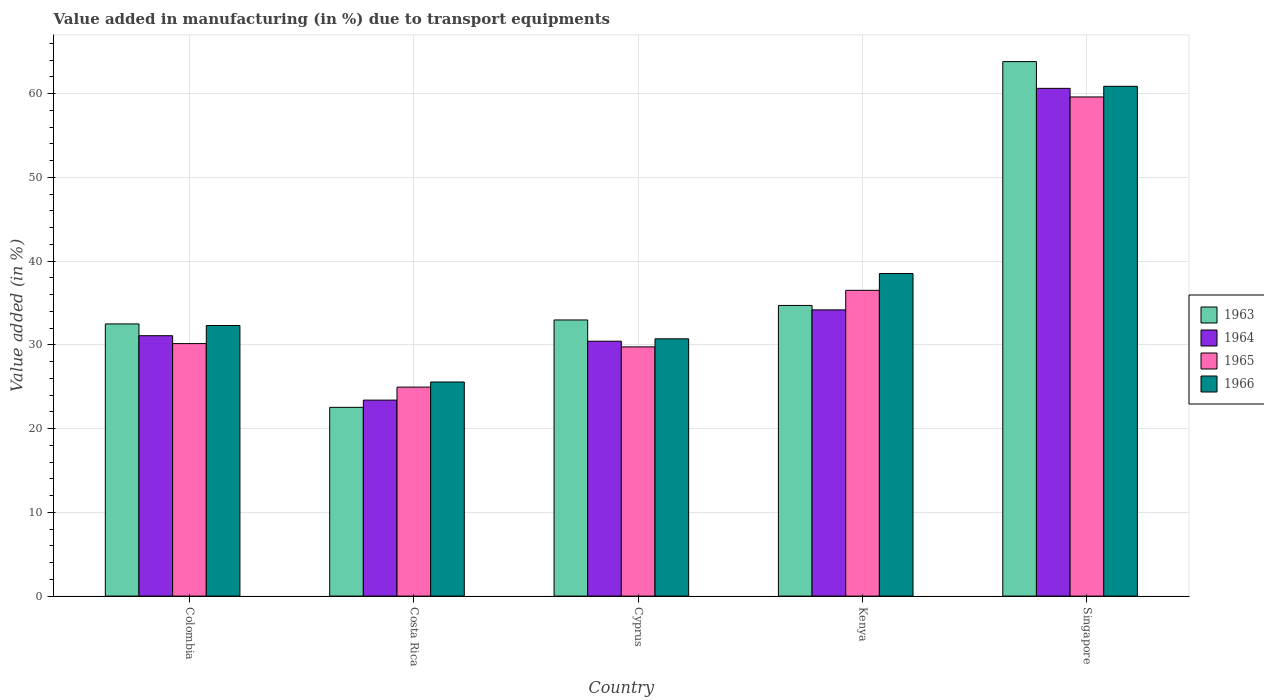How many different coloured bars are there?
Make the answer very short. 4. Are the number of bars per tick equal to the number of legend labels?
Ensure brevity in your answer.  Yes. Are the number of bars on each tick of the X-axis equal?
Provide a succinct answer. Yes. How many bars are there on the 4th tick from the left?
Your response must be concise. 4. How many bars are there on the 2nd tick from the right?
Make the answer very short. 4. What is the label of the 1st group of bars from the left?
Offer a terse response. Colombia. What is the percentage of value added in manufacturing due to transport equipments in 1963 in Costa Rica?
Keep it short and to the point. 22.53. Across all countries, what is the maximum percentage of value added in manufacturing due to transport equipments in 1966?
Your answer should be very brief. 60.86. Across all countries, what is the minimum percentage of value added in manufacturing due to transport equipments in 1965?
Provide a short and direct response. 24.95. In which country was the percentage of value added in manufacturing due to transport equipments in 1965 maximum?
Provide a short and direct response. Singapore. In which country was the percentage of value added in manufacturing due to transport equipments in 1963 minimum?
Offer a very short reply. Costa Rica. What is the total percentage of value added in manufacturing due to transport equipments in 1963 in the graph?
Your answer should be compact. 186.5. What is the difference between the percentage of value added in manufacturing due to transport equipments in 1966 in Colombia and that in Singapore?
Give a very brief answer. -28.56. What is the difference between the percentage of value added in manufacturing due to transport equipments in 1966 in Cyprus and the percentage of value added in manufacturing due to transport equipments in 1965 in Colombia?
Offer a very short reply. 0.57. What is the average percentage of value added in manufacturing due to transport equipments in 1963 per country?
Provide a succinct answer. 37.3. What is the difference between the percentage of value added in manufacturing due to transport equipments of/in 1964 and percentage of value added in manufacturing due to transport equipments of/in 1966 in Colombia?
Give a very brief answer. -1.22. In how many countries, is the percentage of value added in manufacturing due to transport equipments in 1965 greater than 30 %?
Your answer should be very brief. 3. What is the ratio of the percentage of value added in manufacturing due to transport equipments in 1963 in Cyprus to that in Kenya?
Provide a succinct answer. 0.95. Is the difference between the percentage of value added in manufacturing due to transport equipments in 1964 in Costa Rica and Cyprus greater than the difference between the percentage of value added in manufacturing due to transport equipments in 1966 in Costa Rica and Cyprus?
Offer a very short reply. No. What is the difference between the highest and the second highest percentage of value added in manufacturing due to transport equipments in 1966?
Make the answer very short. -28.56. What is the difference between the highest and the lowest percentage of value added in manufacturing due to transport equipments in 1966?
Your response must be concise. 35.3. Is the sum of the percentage of value added in manufacturing due to transport equipments in 1964 in Cyprus and Kenya greater than the maximum percentage of value added in manufacturing due to transport equipments in 1965 across all countries?
Your answer should be compact. Yes. Is it the case that in every country, the sum of the percentage of value added in manufacturing due to transport equipments in 1963 and percentage of value added in manufacturing due to transport equipments in 1965 is greater than the sum of percentage of value added in manufacturing due to transport equipments in 1964 and percentage of value added in manufacturing due to transport equipments in 1966?
Provide a succinct answer. No. What does the 1st bar from the right in Cyprus represents?
Your answer should be very brief. 1966. Is it the case that in every country, the sum of the percentage of value added in manufacturing due to transport equipments in 1964 and percentage of value added in manufacturing due to transport equipments in 1965 is greater than the percentage of value added in manufacturing due to transport equipments in 1966?
Offer a terse response. Yes. What is the difference between two consecutive major ticks on the Y-axis?
Your response must be concise. 10. Are the values on the major ticks of Y-axis written in scientific E-notation?
Provide a succinct answer. No. Does the graph contain any zero values?
Your answer should be compact. No. Where does the legend appear in the graph?
Provide a short and direct response. Center right. How are the legend labels stacked?
Offer a very short reply. Vertical. What is the title of the graph?
Ensure brevity in your answer.  Value added in manufacturing (in %) due to transport equipments. What is the label or title of the Y-axis?
Your answer should be very brief. Value added (in %). What is the Value added (in %) in 1963 in Colombia?
Give a very brief answer. 32.49. What is the Value added (in %) of 1964 in Colombia?
Ensure brevity in your answer.  31.09. What is the Value added (in %) of 1965 in Colombia?
Offer a very short reply. 30.15. What is the Value added (in %) of 1966 in Colombia?
Provide a succinct answer. 32.3. What is the Value added (in %) in 1963 in Costa Rica?
Give a very brief answer. 22.53. What is the Value added (in %) in 1964 in Costa Rica?
Offer a very short reply. 23.4. What is the Value added (in %) of 1965 in Costa Rica?
Your answer should be very brief. 24.95. What is the Value added (in %) of 1966 in Costa Rica?
Make the answer very short. 25.56. What is the Value added (in %) of 1963 in Cyprus?
Make the answer very short. 32.97. What is the Value added (in %) in 1964 in Cyprus?
Your answer should be very brief. 30.43. What is the Value added (in %) of 1965 in Cyprus?
Keep it short and to the point. 29.75. What is the Value added (in %) of 1966 in Cyprus?
Ensure brevity in your answer.  30.72. What is the Value added (in %) of 1963 in Kenya?
Your answer should be very brief. 34.7. What is the Value added (in %) of 1964 in Kenya?
Keep it short and to the point. 34.17. What is the Value added (in %) of 1965 in Kenya?
Keep it short and to the point. 36.5. What is the Value added (in %) in 1966 in Kenya?
Offer a very short reply. 38.51. What is the Value added (in %) in 1963 in Singapore?
Provide a short and direct response. 63.81. What is the Value added (in %) in 1964 in Singapore?
Give a very brief answer. 60.62. What is the Value added (in %) of 1965 in Singapore?
Provide a short and direct response. 59.59. What is the Value added (in %) in 1966 in Singapore?
Ensure brevity in your answer.  60.86. Across all countries, what is the maximum Value added (in %) of 1963?
Make the answer very short. 63.81. Across all countries, what is the maximum Value added (in %) in 1964?
Make the answer very short. 60.62. Across all countries, what is the maximum Value added (in %) of 1965?
Offer a very short reply. 59.59. Across all countries, what is the maximum Value added (in %) of 1966?
Make the answer very short. 60.86. Across all countries, what is the minimum Value added (in %) in 1963?
Your response must be concise. 22.53. Across all countries, what is the minimum Value added (in %) in 1964?
Ensure brevity in your answer.  23.4. Across all countries, what is the minimum Value added (in %) of 1965?
Your response must be concise. 24.95. Across all countries, what is the minimum Value added (in %) of 1966?
Ensure brevity in your answer.  25.56. What is the total Value added (in %) in 1963 in the graph?
Keep it short and to the point. 186.5. What is the total Value added (in %) in 1964 in the graph?
Your answer should be very brief. 179.7. What is the total Value added (in %) of 1965 in the graph?
Give a very brief answer. 180.94. What is the total Value added (in %) in 1966 in the graph?
Your response must be concise. 187.95. What is the difference between the Value added (in %) of 1963 in Colombia and that in Costa Rica?
Your answer should be compact. 9.96. What is the difference between the Value added (in %) in 1964 in Colombia and that in Costa Rica?
Offer a terse response. 7.69. What is the difference between the Value added (in %) in 1965 in Colombia and that in Costa Rica?
Give a very brief answer. 5.2. What is the difference between the Value added (in %) of 1966 in Colombia and that in Costa Rica?
Keep it short and to the point. 6.74. What is the difference between the Value added (in %) of 1963 in Colombia and that in Cyprus?
Give a very brief answer. -0.47. What is the difference between the Value added (in %) of 1964 in Colombia and that in Cyprus?
Offer a very short reply. 0.66. What is the difference between the Value added (in %) in 1965 in Colombia and that in Cyprus?
Make the answer very short. 0.39. What is the difference between the Value added (in %) in 1966 in Colombia and that in Cyprus?
Give a very brief answer. 1.59. What is the difference between the Value added (in %) in 1963 in Colombia and that in Kenya?
Your answer should be compact. -2.21. What is the difference between the Value added (in %) of 1964 in Colombia and that in Kenya?
Keep it short and to the point. -3.08. What is the difference between the Value added (in %) of 1965 in Colombia and that in Kenya?
Your answer should be compact. -6.36. What is the difference between the Value added (in %) of 1966 in Colombia and that in Kenya?
Ensure brevity in your answer.  -6.2. What is the difference between the Value added (in %) in 1963 in Colombia and that in Singapore?
Ensure brevity in your answer.  -31.32. What is the difference between the Value added (in %) of 1964 in Colombia and that in Singapore?
Offer a very short reply. -29.53. What is the difference between the Value added (in %) of 1965 in Colombia and that in Singapore?
Offer a terse response. -29.45. What is the difference between the Value added (in %) in 1966 in Colombia and that in Singapore?
Offer a terse response. -28.56. What is the difference between the Value added (in %) of 1963 in Costa Rica and that in Cyprus?
Your answer should be very brief. -10.43. What is the difference between the Value added (in %) of 1964 in Costa Rica and that in Cyprus?
Offer a terse response. -7.03. What is the difference between the Value added (in %) of 1965 in Costa Rica and that in Cyprus?
Give a very brief answer. -4.8. What is the difference between the Value added (in %) in 1966 in Costa Rica and that in Cyprus?
Your response must be concise. -5.16. What is the difference between the Value added (in %) in 1963 in Costa Rica and that in Kenya?
Ensure brevity in your answer.  -12.17. What is the difference between the Value added (in %) in 1964 in Costa Rica and that in Kenya?
Offer a very short reply. -10.77. What is the difference between the Value added (in %) of 1965 in Costa Rica and that in Kenya?
Your response must be concise. -11.55. What is the difference between the Value added (in %) in 1966 in Costa Rica and that in Kenya?
Your answer should be compact. -12.95. What is the difference between the Value added (in %) in 1963 in Costa Rica and that in Singapore?
Provide a succinct answer. -41.28. What is the difference between the Value added (in %) of 1964 in Costa Rica and that in Singapore?
Give a very brief answer. -37.22. What is the difference between the Value added (in %) of 1965 in Costa Rica and that in Singapore?
Provide a succinct answer. -34.64. What is the difference between the Value added (in %) of 1966 in Costa Rica and that in Singapore?
Your response must be concise. -35.3. What is the difference between the Value added (in %) in 1963 in Cyprus and that in Kenya?
Offer a terse response. -1.73. What is the difference between the Value added (in %) in 1964 in Cyprus and that in Kenya?
Make the answer very short. -3.74. What is the difference between the Value added (in %) of 1965 in Cyprus and that in Kenya?
Give a very brief answer. -6.75. What is the difference between the Value added (in %) of 1966 in Cyprus and that in Kenya?
Your answer should be very brief. -7.79. What is the difference between the Value added (in %) in 1963 in Cyprus and that in Singapore?
Your response must be concise. -30.84. What is the difference between the Value added (in %) in 1964 in Cyprus and that in Singapore?
Keep it short and to the point. -30.19. What is the difference between the Value added (in %) in 1965 in Cyprus and that in Singapore?
Your answer should be compact. -29.84. What is the difference between the Value added (in %) of 1966 in Cyprus and that in Singapore?
Your answer should be very brief. -30.14. What is the difference between the Value added (in %) of 1963 in Kenya and that in Singapore?
Give a very brief answer. -29.11. What is the difference between the Value added (in %) in 1964 in Kenya and that in Singapore?
Give a very brief answer. -26.45. What is the difference between the Value added (in %) of 1965 in Kenya and that in Singapore?
Provide a short and direct response. -23.09. What is the difference between the Value added (in %) in 1966 in Kenya and that in Singapore?
Give a very brief answer. -22.35. What is the difference between the Value added (in %) of 1963 in Colombia and the Value added (in %) of 1964 in Costa Rica?
Provide a short and direct response. 9.1. What is the difference between the Value added (in %) of 1963 in Colombia and the Value added (in %) of 1965 in Costa Rica?
Your answer should be compact. 7.54. What is the difference between the Value added (in %) of 1963 in Colombia and the Value added (in %) of 1966 in Costa Rica?
Your answer should be compact. 6.93. What is the difference between the Value added (in %) of 1964 in Colombia and the Value added (in %) of 1965 in Costa Rica?
Offer a very short reply. 6.14. What is the difference between the Value added (in %) of 1964 in Colombia and the Value added (in %) of 1966 in Costa Rica?
Provide a succinct answer. 5.53. What is the difference between the Value added (in %) of 1965 in Colombia and the Value added (in %) of 1966 in Costa Rica?
Ensure brevity in your answer.  4.59. What is the difference between the Value added (in %) of 1963 in Colombia and the Value added (in %) of 1964 in Cyprus?
Your response must be concise. 2.06. What is the difference between the Value added (in %) in 1963 in Colombia and the Value added (in %) in 1965 in Cyprus?
Offer a very short reply. 2.74. What is the difference between the Value added (in %) of 1963 in Colombia and the Value added (in %) of 1966 in Cyprus?
Provide a short and direct response. 1.78. What is the difference between the Value added (in %) of 1964 in Colombia and the Value added (in %) of 1965 in Cyprus?
Provide a short and direct response. 1.33. What is the difference between the Value added (in %) in 1964 in Colombia and the Value added (in %) in 1966 in Cyprus?
Give a very brief answer. 0.37. What is the difference between the Value added (in %) in 1965 in Colombia and the Value added (in %) in 1966 in Cyprus?
Provide a succinct answer. -0.57. What is the difference between the Value added (in %) of 1963 in Colombia and the Value added (in %) of 1964 in Kenya?
Keep it short and to the point. -1.68. What is the difference between the Value added (in %) in 1963 in Colombia and the Value added (in %) in 1965 in Kenya?
Ensure brevity in your answer.  -4.01. What is the difference between the Value added (in %) in 1963 in Colombia and the Value added (in %) in 1966 in Kenya?
Ensure brevity in your answer.  -6.01. What is the difference between the Value added (in %) in 1964 in Colombia and the Value added (in %) in 1965 in Kenya?
Ensure brevity in your answer.  -5.42. What is the difference between the Value added (in %) in 1964 in Colombia and the Value added (in %) in 1966 in Kenya?
Make the answer very short. -7.42. What is the difference between the Value added (in %) in 1965 in Colombia and the Value added (in %) in 1966 in Kenya?
Give a very brief answer. -8.36. What is the difference between the Value added (in %) in 1963 in Colombia and the Value added (in %) in 1964 in Singapore?
Offer a very short reply. -28.12. What is the difference between the Value added (in %) in 1963 in Colombia and the Value added (in %) in 1965 in Singapore?
Ensure brevity in your answer.  -27.1. What is the difference between the Value added (in %) of 1963 in Colombia and the Value added (in %) of 1966 in Singapore?
Your response must be concise. -28.37. What is the difference between the Value added (in %) in 1964 in Colombia and the Value added (in %) in 1965 in Singapore?
Your answer should be very brief. -28.51. What is the difference between the Value added (in %) in 1964 in Colombia and the Value added (in %) in 1966 in Singapore?
Your answer should be compact. -29.77. What is the difference between the Value added (in %) of 1965 in Colombia and the Value added (in %) of 1966 in Singapore?
Make the answer very short. -30.71. What is the difference between the Value added (in %) in 1963 in Costa Rica and the Value added (in %) in 1964 in Cyprus?
Your answer should be compact. -7.9. What is the difference between the Value added (in %) of 1963 in Costa Rica and the Value added (in %) of 1965 in Cyprus?
Keep it short and to the point. -7.22. What is the difference between the Value added (in %) in 1963 in Costa Rica and the Value added (in %) in 1966 in Cyprus?
Make the answer very short. -8.18. What is the difference between the Value added (in %) in 1964 in Costa Rica and the Value added (in %) in 1965 in Cyprus?
Give a very brief answer. -6.36. What is the difference between the Value added (in %) of 1964 in Costa Rica and the Value added (in %) of 1966 in Cyprus?
Ensure brevity in your answer.  -7.32. What is the difference between the Value added (in %) of 1965 in Costa Rica and the Value added (in %) of 1966 in Cyprus?
Offer a very short reply. -5.77. What is the difference between the Value added (in %) of 1963 in Costa Rica and the Value added (in %) of 1964 in Kenya?
Ensure brevity in your answer.  -11.64. What is the difference between the Value added (in %) of 1963 in Costa Rica and the Value added (in %) of 1965 in Kenya?
Your answer should be very brief. -13.97. What is the difference between the Value added (in %) in 1963 in Costa Rica and the Value added (in %) in 1966 in Kenya?
Provide a short and direct response. -15.97. What is the difference between the Value added (in %) in 1964 in Costa Rica and the Value added (in %) in 1965 in Kenya?
Your answer should be very brief. -13.11. What is the difference between the Value added (in %) of 1964 in Costa Rica and the Value added (in %) of 1966 in Kenya?
Offer a terse response. -15.11. What is the difference between the Value added (in %) in 1965 in Costa Rica and the Value added (in %) in 1966 in Kenya?
Keep it short and to the point. -13.56. What is the difference between the Value added (in %) of 1963 in Costa Rica and the Value added (in %) of 1964 in Singapore?
Your answer should be very brief. -38.08. What is the difference between the Value added (in %) of 1963 in Costa Rica and the Value added (in %) of 1965 in Singapore?
Offer a terse response. -37.06. What is the difference between the Value added (in %) of 1963 in Costa Rica and the Value added (in %) of 1966 in Singapore?
Give a very brief answer. -38.33. What is the difference between the Value added (in %) in 1964 in Costa Rica and the Value added (in %) in 1965 in Singapore?
Keep it short and to the point. -36.19. What is the difference between the Value added (in %) of 1964 in Costa Rica and the Value added (in %) of 1966 in Singapore?
Keep it short and to the point. -37.46. What is the difference between the Value added (in %) in 1965 in Costa Rica and the Value added (in %) in 1966 in Singapore?
Your answer should be compact. -35.91. What is the difference between the Value added (in %) in 1963 in Cyprus and the Value added (in %) in 1964 in Kenya?
Ensure brevity in your answer.  -1.2. What is the difference between the Value added (in %) in 1963 in Cyprus and the Value added (in %) in 1965 in Kenya?
Offer a very short reply. -3.54. What is the difference between the Value added (in %) in 1963 in Cyprus and the Value added (in %) in 1966 in Kenya?
Offer a terse response. -5.54. What is the difference between the Value added (in %) of 1964 in Cyprus and the Value added (in %) of 1965 in Kenya?
Provide a short and direct response. -6.07. What is the difference between the Value added (in %) of 1964 in Cyprus and the Value added (in %) of 1966 in Kenya?
Provide a short and direct response. -8.08. What is the difference between the Value added (in %) in 1965 in Cyprus and the Value added (in %) in 1966 in Kenya?
Give a very brief answer. -8.75. What is the difference between the Value added (in %) of 1963 in Cyprus and the Value added (in %) of 1964 in Singapore?
Give a very brief answer. -27.65. What is the difference between the Value added (in %) of 1963 in Cyprus and the Value added (in %) of 1965 in Singapore?
Ensure brevity in your answer.  -26.62. What is the difference between the Value added (in %) in 1963 in Cyprus and the Value added (in %) in 1966 in Singapore?
Provide a succinct answer. -27.89. What is the difference between the Value added (in %) in 1964 in Cyprus and the Value added (in %) in 1965 in Singapore?
Give a very brief answer. -29.16. What is the difference between the Value added (in %) of 1964 in Cyprus and the Value added (in %) of 1966 in Singapore?
Ensure brevity in your answer.  -30.43. What is the difference between the Value added (in %) of 1965 in Cyprus and the Value added (in %) of 1966 in Singapore?
Provide a short and direct response. -31.11. What is the difference between the Value added (in %) in 1963 in Kenya and the Value added (in %) in 1964 in Singapore?
Offer a terse response. -25.92. What is the difference between the Value added (in %) in 1963 in Kenya and the Value added (in %) in 1965 in Singapore?
Keep it short and to the point. -24.89. What is the difference between the Value added (in %) of 1963 in Kenya and the Value added (in %) of 1966 in Singapore?
Offer a terse response. -26.16. What is the difference between the Value added (in %) in 1964 in Kenya and the Value added (in %) in 1965 in Singapore?
Your answer should be compact. -25.42. What is the difference between the Value added (in %) of 1964 in Kenya and the Value added (in %) of 1966 in Singapore?
Your answer should be compact. -26.69. What is the difference between the Value added (in %) of 1965 in Kenya and the Value added (in %) of 1966 in Singapore?
Provide a succinct answer. -24.36. What is the average Value added (in %) in 1963 per country?
Offer a very short reply. 37.3. What is the average Value added (in %) of 1964 per country?
Provide a short and direct response. 35.94. What is the average Value added (in %) of 1965 per country?
Your answer should be compact. 36.19. What is the average Value added (in %) of 1966 per country?
Your answer should be very brief. 37.59. What is the difference between the Value added (in %) of 1963 and Value added (in %) of 1964 in Colombia?
Provide a succinct answer. 1.41. What is the difference between the Value added (in %) in 1963 and Value added (in %) in 1965 in Colombia?
Offer a terse response. 2.35. What is the difference between the Value added (in %) in 1963 and Value added (in %) in 1966 in Colombia?
Your answer should be compact. 0.19. What is the difference between the Value added (in %) in 1964 and Value added (in %) in 1965 in Colombia?
Provide a short and direct response. 0.94. What is the difference between the Value added (in %) in 1964 and Value added (in %) in 1966 in Colombia?
Offer a very short reply. -1.22. What is the difference between the Value added (in %) of 1965 and Value added (in %) of 1966 in Colombia?
Offer a terse response. -2.16. What is the difference between the Value added (in %) in 1963 and Value added (in %) in 1964 in Costa Rica?
Make the answer very short. -0.86. What is the difference between the Value added (in %) of 1963 and Value added (in %) of 1965 in Costa Rica?
Your answer should be compact. -2.42. What is the difference between the Value added (in %) in 1963 and Value added (in %) in 1966 in Costa Rica?
Offer a terse response. -3.03. What is the difference between the Value added (in %) of 1964 and Value added (in %) of 1965 in Costa Rica?
Provide a short and direct response. -1.55. What is the difference between the Value added (in %) in 1964 and Value added (in %) in 1966 in Costa Rica?
Your answer should be very brief. -2.16. What is the difference between the Value added (in %) of 1965 and Value added (in %) of 1966 in Costa Rica?
Make the answer very short. -0.61. What is the difference between the Value added (in %) of 1963 and Value added (in %) of 1964 in Cyprus?
Your answer should be compact. 2.54. What is the difference between the Value added (in %) of 1963 and Value added (in %) of 1965 in Cyprus?
Offer a terse response. 3.21. What is the difference between the Value added (in %) of 1963 and Value added (in %) of 1966 in Cyprus?
Your response must be concise. 2.25. What is the difference between the Value added (in %) of 1964 and Value added (in %) of 1965 in Cyprus?
Your response must be concise. 0.68. What is the difference between the Value added (in %) of 1964 and Value added (in %) of 1966 in Cyprus?
Give a very brief answer. -0.29. What is the difference between the Value added (in %) of 1965 and Value added (in %) of 1966 in Cyprus?
Ensure brevity in your answer.  -0.96. What is the difference between the Value added (in %) of 1963 and Value added (in %) of 1964 in Kenya?
Offer a very short reply. 0.53. What is the difference between the Value added (in %) in 1963 and Value added (in %) in 1965 in Kenya?
Your response must be concise. -1.8. What is the difference between the Value added (in %) of 1963 and Value added (in %) of 1966 in Kenya?
Your answer should be compact. -3.81. What is the difference between the Value added (in %) of 1964 and Value added (in %) of 1965 in Kenya?
Offer a very short reply. -2.33. What is the difference between the Value added (in %) in 1964 and Value added (in %) in 1966 in Kenya?
Your answer should be very brief. -4.34. What is the difference between the Value added (in %) in 1965 and Value added (in %) in 1966 in Kenya?
Offer a very short reply. -2. What is the difference between the Value added (in %) of 1963 and Value added (in %) of 1964 in Singapore?
Provide a short and direct response. 3.19. What is the difference between the Value added (in %) in 1963 and Value added (in %) in 1965 in Singapore?
Your answer should be compact. 4.22. What is the difference between the Value added (in %) of 1963 and Value added (in %) of 1966 in Singapore?
Your answer should be compact. 2.95. What is the difference between the Value added (in %) in 1964 and Value added (in %) in 1965 in Singapore?
Provide a succinct answer. 1.03. What is the difference between the Value added (in %) of 1964 and Value added (in %) of 1966 in Singapore?
Make the answer very short. -0.24. What is the difference between the Value added (in %) in 1965 and Value added (in %) in 1966 in Singapore?
Offer a terse response. -1.27. What is the ratio of the Value added (in %) of 1963 in Colombia to that in Costa Rica?
Ensure brevity in your answer.  1.44. What is the ratio of the Value added (in %) of 1964 in Colombia to that in Costa Rica?
Give a very brief answer. 1.33. What is the ratio of the Value added (in %) in 1965 in Colombia to that in Costa Rica?
Give a very brief answer. 1.21. What is the ratio of the Value added (in %) of 1966 in Colombia to that in Costa Rica?
Keep it short and to the point. 1.26. What is the ratio of the Value added (in %) of 1963 in Colombia to that in Cyprus?
Make the answer very short. 0.99. What is the ratio of the Value added (in %) in 1964 in Colombia to that in Cyprus?
Offer a very short reply. 1.02. What is the ratio of the Value added (in %) in 1965 in Colombia to that in Cyprus?
Offer a terse response. 1.01. What is the ratio of the Value added (in %) of 1966 in Colombia to that in Cyprus?
Ensure brevity in your answer.  1.05. What is the ratio of the Value added (in %) in 1963 in Colombia to that in Kenya?
Your answer should be compact. 0.94. What is the ratio of the Value added (in %) of 1964 in Colombia to that in Kenya?
Ensure brevity in your answer.  0.91. What is the ratio of the Value added (in %) of 1965 in Colombia to that in Kenya?
Ensure brevity in your answer.  0.83. What is the ratio of the Value added (in %) of 1966 in Colombia to that in Kenya?
Your response must be concise. 0.84. What is the ratio of the Value added (in %) of 1963 in Colombia to that in Singapore?
Keep it short and to the point. 0.51. What is the ratio of the Value added (in %) in 1964 in Colombia to that in Singapore?
Provide a short and direct response. 0.51. What is the ratio of the Value added (in %) of 1965 in Colombia to that in Singapore?
Provide a short and direct response. 0.51. What is the ratio of the Value added (in %) of 1966 in Colombia to that in Singapore?
Provide a short and direct response. 0.53. What is the ratio of the Value added (in %) in 1963 in Costa Rica to that in Cyprus?
Offer a very short reply. 0.68. What is the ratio of the Value added (in %) in 1964 in Costa Rica to that in Cyprus?
Your answer should be very brief. 0.77. What is the ratio of the Value added (in %) in 1965 in Costa Rica to that in Cyprus?
Give a very brief answer. 0.84. What is the ratio of the Value added (in %) in 1966 in Costa Rica to that in Cyprus?
Your answer should be very brief. 0.83. What is the ratio of the Value added (in %) in 1963 in Costa Rica to that in Kenya?
Make the answer very short. 0.65. What is the ratio of the Value added (in %) of 1964 in Costa Rica to that in Kenya?
Provide a short and direct response. 0.68. What is the ratio of the Value added (in %) of 1965 in Costa Rica to that in Kenya?
Your answer should be very brief. 0.68. What is the ratio of the Value added (in %) of 1966 in Costa Rica to that in Kenya?
Make the answer very short. 0.66. What is the ratio of the Value added (in %) of 1963 in Costa Rica to that in Singapore?
Give a very brief answer. 0.35. What is the ratio of the Value added (in %) of 1964 in Costa Rica to that in Singapore?
Your response must be concise. 0.39. What is the ratio of the Value added (in %) of 1965 in Costa Rica to that in Singapore?
Make the answer very short. 0.42. What is the ratio of the Value added (in %) of 1966 in Costa Rica to that in Singapore?
Your answer should be very brief. 0.42. What is the ratio of the Value added (in %) in 1963 in Cyprus to that in Kenya?
Your answer should be compact. 0.95. What is the ratio of the Value added (in %) of 1964 in Cyprus to that in Kenya?
Your answer should be compact. 0.89. What is the ratio of the Value added (in %) of 1965 in Cyprus to that in Kenya?
Offer a terse response. 0.82. What is the ratio of the Value added (in %) of 1966 in Cyprus to that in Kenya?
Ensure brevity in your answer.  0.8. What is the ratio of the Value added (in %) in 1963 in Cyprus to that in Singapore?
Provide a succinct answer. 0.52. What is the ratio of the Value added (in %) in 1964 in Cyprus to that in Singapore?
Offer a very short reply. 0.5. What is the ratio of the Value added (in %) of 1965 in Cyprus to that in Singapore?
Your answer should be compact. 0.5. What is the ratio of the Value added (in %) of 1966 in Cyprus to that in Singapore?
Provide a succinct answer. 0.5. What is the ratio of the Value added (in %) of 1963 in Kenya to that in Singapore?
Make the answer very short. 0.54. What is the ratio of the Value added (in %) of 1964 in Kenya to that in Singapore?
Provide a succinct answer. 0.56. What is the ratio of the Value added (in %) of 1965 in Kenya to that in Singapore?
Your answer should be compact. 0.61. What is the ratio of the Value added (in %) of 1966 in Kenya to that in Singapore?
Provide a short and direct response. 0.63. What is the difference between the highest and the second highest Value added (in %) in 1963?
Your response must be concise. 29.11. What is the difference between the highest and the second highest Value added (in %) in 1964?
Keep it short and to the point. 26.45. What is the difference between the highest and the second highest Value added (in %) of 1965?
Make the answer very short. 23.09. What is the difference between the highest and the second highest Value added (in %) of 1966?
Give a very brief answer. 22.35. What is the difference between the highest and the lowest Value added (in %) of 1963?
Provide a succinct answer. 41.28. What is the difference between the highest and the lowest Value added (in %) of 1964?
Keep it short and to the point. 37.22. What is the difference between the highest and the lowest Value added (in %) of 1965?
Provide a short and direct response. 34.64. What is the difference between the highest and the lowest Value added (in %) in 1966?
Offer a very short reply. 35.3. 